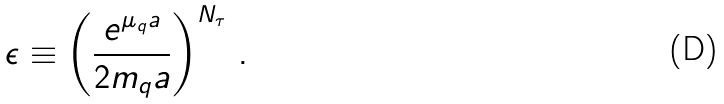<formula> <loc_0><loc_0><loc_500><loc_500>\epsilon \equiv \left ( \frac { e ^ { \mu _ { q } a } } { 2 m _ { q } a } \right ) ^ { N _ { \tau } } \, .</formula> 